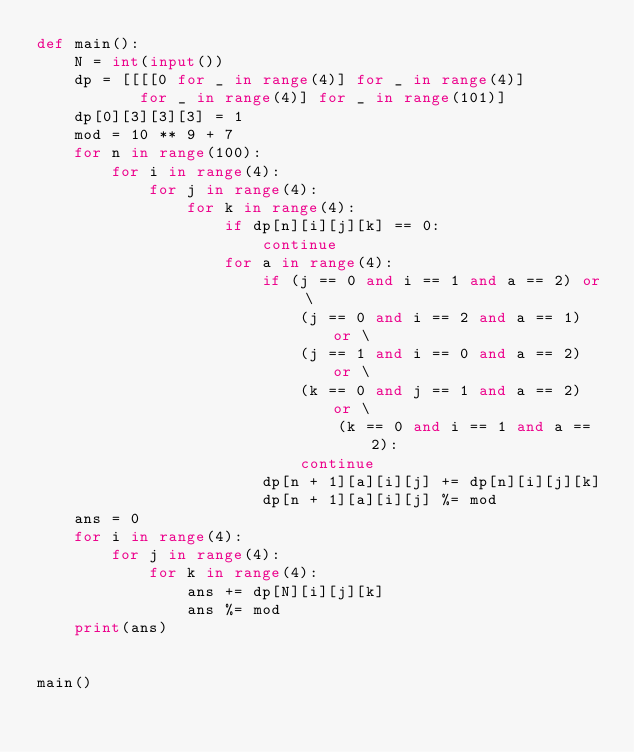Convert code to text. <code><loc_0><loc_0><loc_500><loc_500><_Python_>def main():
    N = int(input())
    dp = [[[[0 for _ in range(4)] for _ in range(4)]
           for _ in range(4)] for _ in range(101)]
    dp[0][3][3][3] = 1
    mod = 10 ** 9 + 7
    for n in range(100):
        for i in range(4):
            for j in range(4):
                for k in range(4):
                    if dp[n][i][j][k] == 0:
                        continue
                    for a in range(4):
                        if (j == 0 and i == 1 and a == 2) or \
                            (j == 0 and i == 2 and a == 1) or \
                            (j == 1 and i == 0 and a == 2) or \
                            (k == 0 and j == 1 and a == 2) or \
                                (k == 0 and i == 1 and a == 2):
                            continue
                        dp[n + 1][a][i][j] += dp[n][i][j][k]
                        dp[n + 1][a][i][j] %= mod
    ans = 0
    for i in range(4):
        for j in range(4):
            for k in range(4):
                ans += dp[N][i][j][k]
                ans %= mod
    print(ans)


main()
</code> 